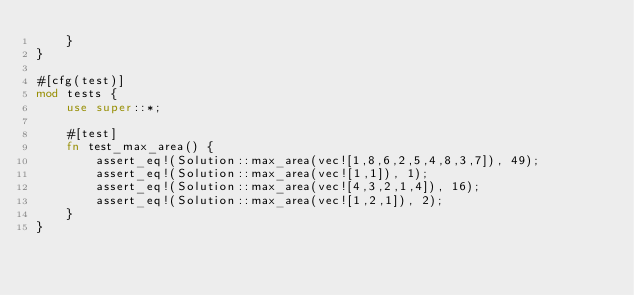<code> <loc_0><loc_0><loc_500><loc_500><_Rust_>    }
}

#[cfg(test)]
mod tests {
    use super::*;

    #[test]
    fn test_max_area() {
        assert_eq!(Solution::max_area(vec![1,8,6,2,5,4,8,3,7]), 49);
        assert_eq!(Solution::max_area(vec![1,1]), 1);
        assert_eq!(Solution::max_area(vec![4,3,2,1,4]), 16);
        assert_eq!(Solution::max_area(vec![1,2,1]), 2);
    }
}
</code> 